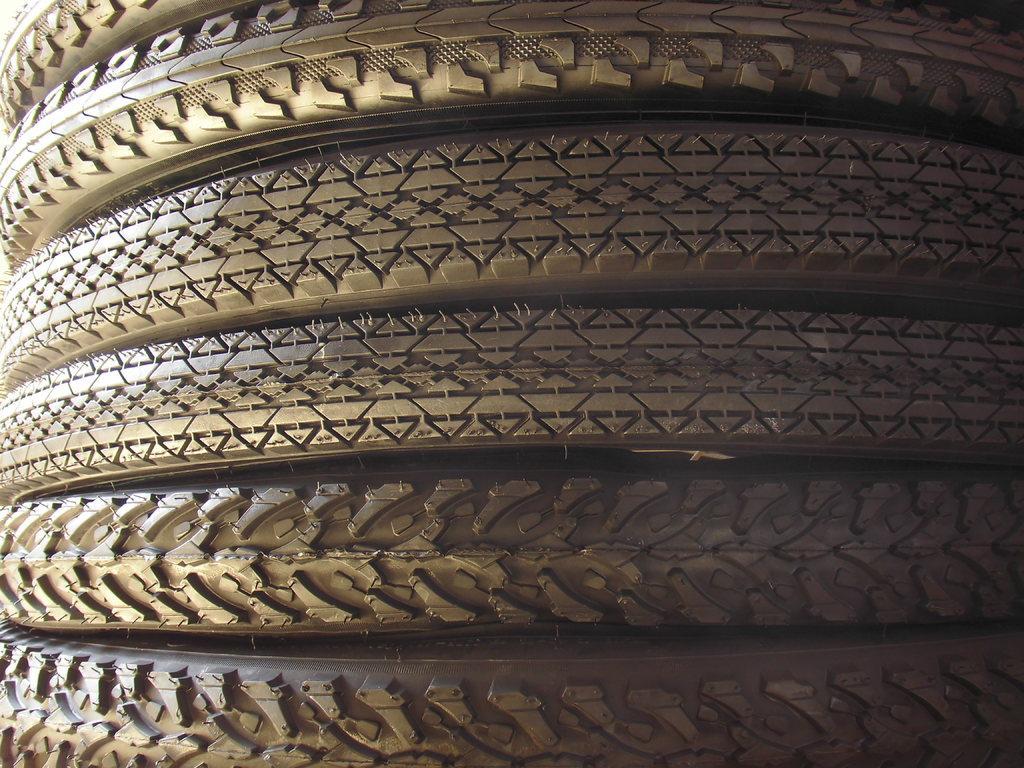Describe this image in one or two sentences. In this picture we can see tires with different tracks. 